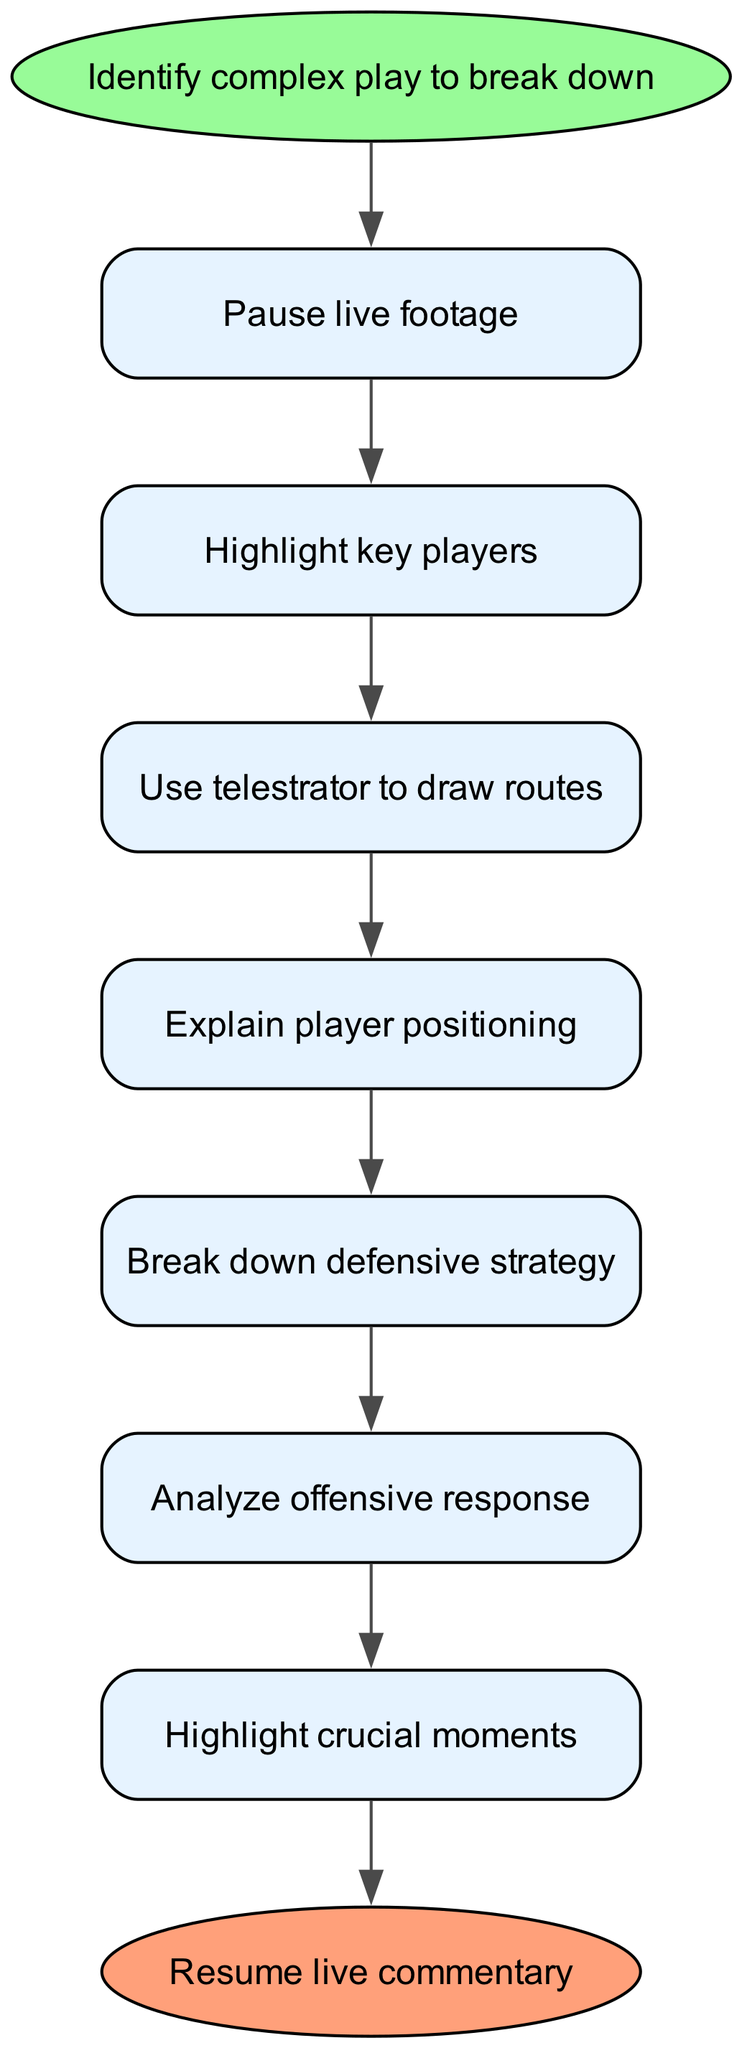What is the first step in the process? The diagram starts with the node labeled "Identify complex play to break down," which indicates the first step to initiate the breakdown process.
Answer: Identify complex play to break down How many steps are in the flow? The diagram includes a total of seven specific steps listed in the steps section, following the initial identification step, making it eight steps altogether.
Answer: Eight What is the last step shown in the diagram? The final step is indicated by the node labeled "Resume live commentary," which signifies the end of the instruction flow.
Answer: Resume live commentary Which step follows "Break down defensive strategy"? According to the flow structure, the next step after "Break down defensive strategy" is "Analyze offensive response." This shows the sequential nature of the instruction process.
Answer: Analyze offensive response How does "Use telestrator to draw routes" relate to "Highlight key players"? The diagram shows that "Use telestrator to draw routes" directly follows "Highlight key players," indicating that after highlighting, the next logical action is to utilize the telestrator to illustrate player movements.
Answer: Directly follows What is the relationship between "Highlight crucial moments" and "Summarize play outcome"? The relationship is that "Highlight crucial moments" is a precursor step that leads into the next step "Summarize play outcome," showing that understanding key events is pivotal before concluding the analysis.
Answer: Precursor step What is the color of the end node in the diagram? The end node is colored '#FFA07A', indicating that it has a distinct color meant to denote its status as the endpoint of the flow.
Answer: '#FFA07A' What does each step represent in the context of the diagram? Each step represents a specific action or focus area in breaking down complex plays for the viewers, illustrating a clear instructional process for analysis during commentary.
Answer: Specific action or focus area 